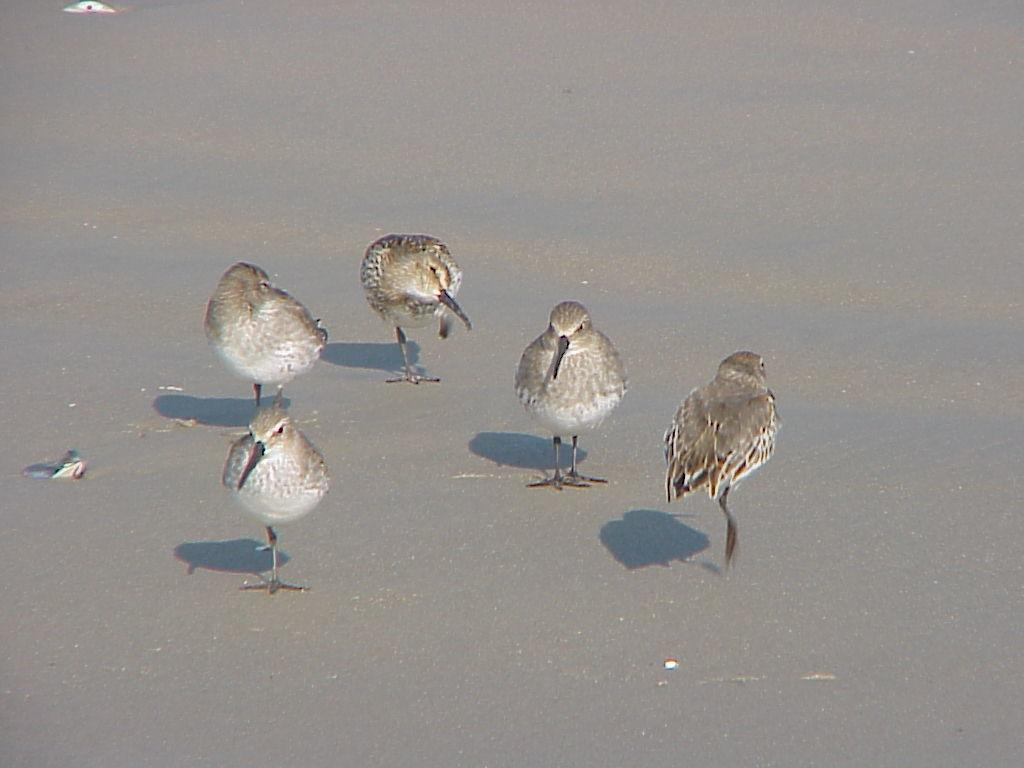What type of animals can be seen in the image? Birds can be seen in the image. What is the birds' position in relation to the surface? The birds are standing on the surface. What type of rail can be seen supporting the birds in the image? There is no rail present in the image; the birds are standing on the surface. 